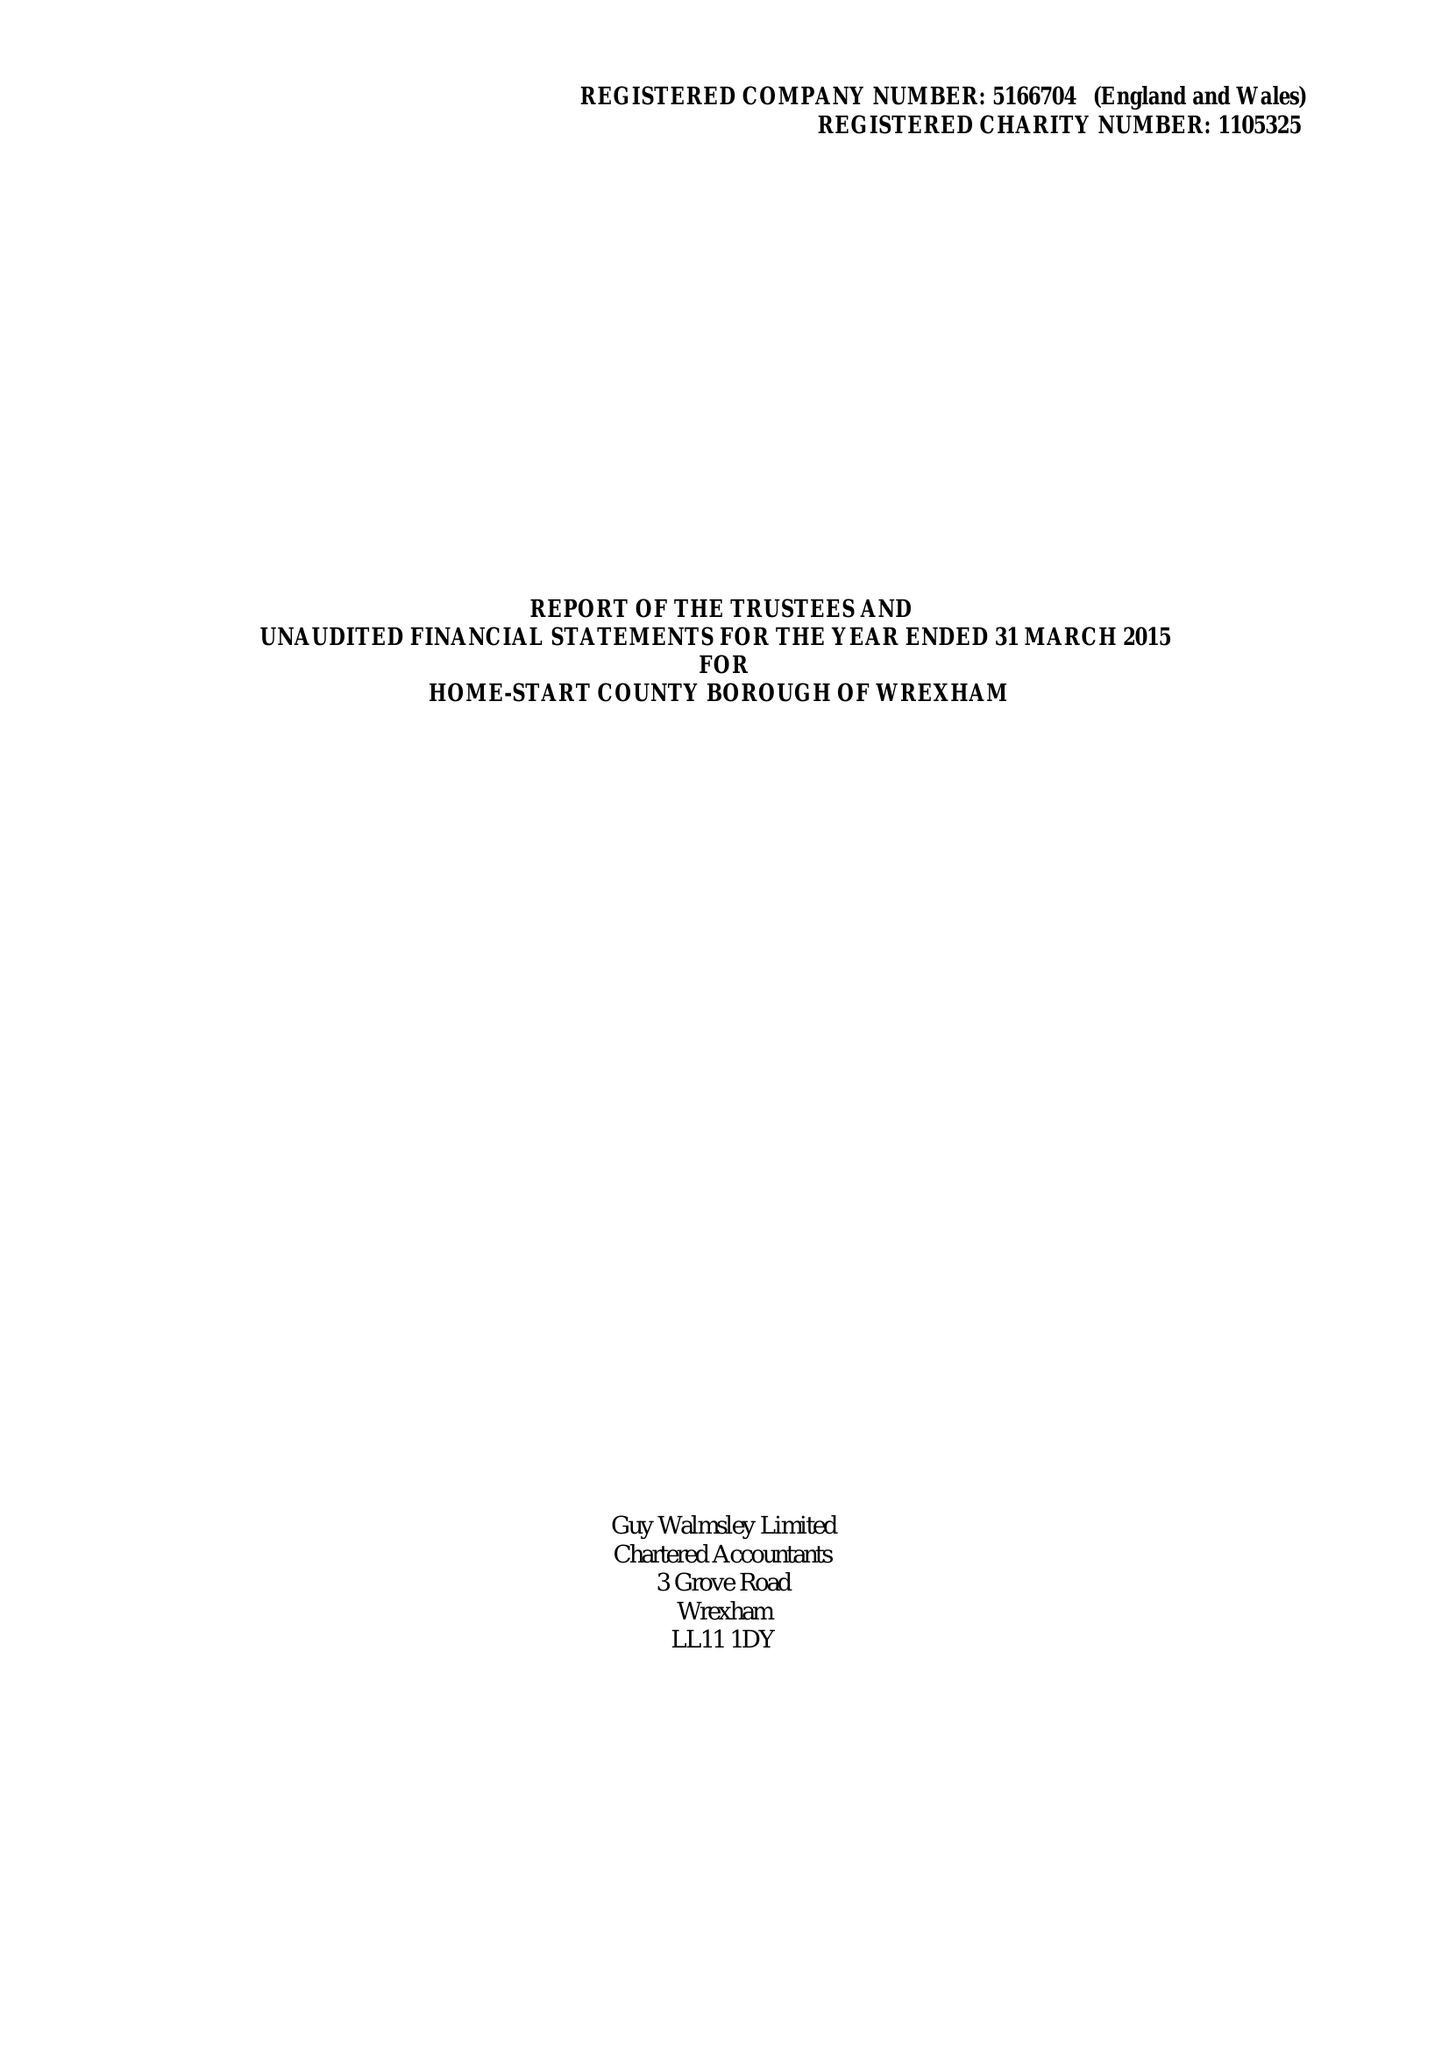What is the value for the income_annually_in_british_pounds?
Answer the question using a single word or phrase. 181131.00 